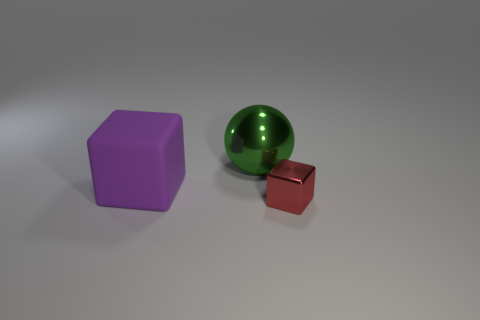Add 1 tiny red shiny things. How many objects exist? 4 Subtract all spheres. How many objects are left? 2 Add 3 large rubber cubes. How many large rubber cubes exist? 4 Subtract 0 gray balls. How many objects are left? 3 Subtract all yellow shiny cubes. Subtract all red things. How many objects are left? 2 Add 1 big green things. How many big green things are left? 2 